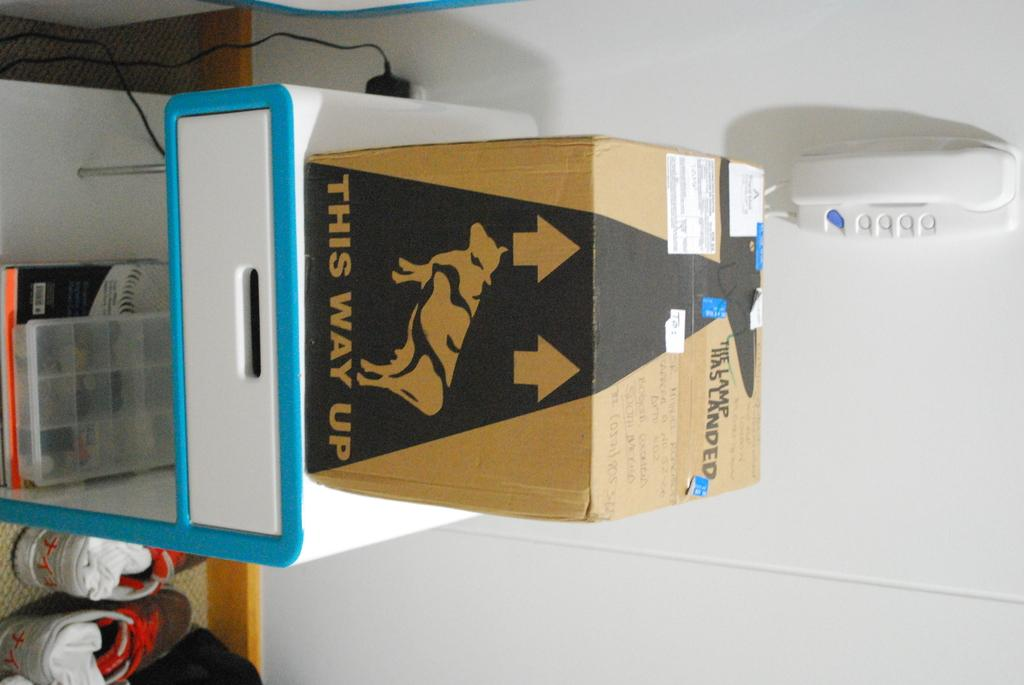<image>
Share a concise interpretation of the image provided. A box with a cow on it says this way up on the side. 